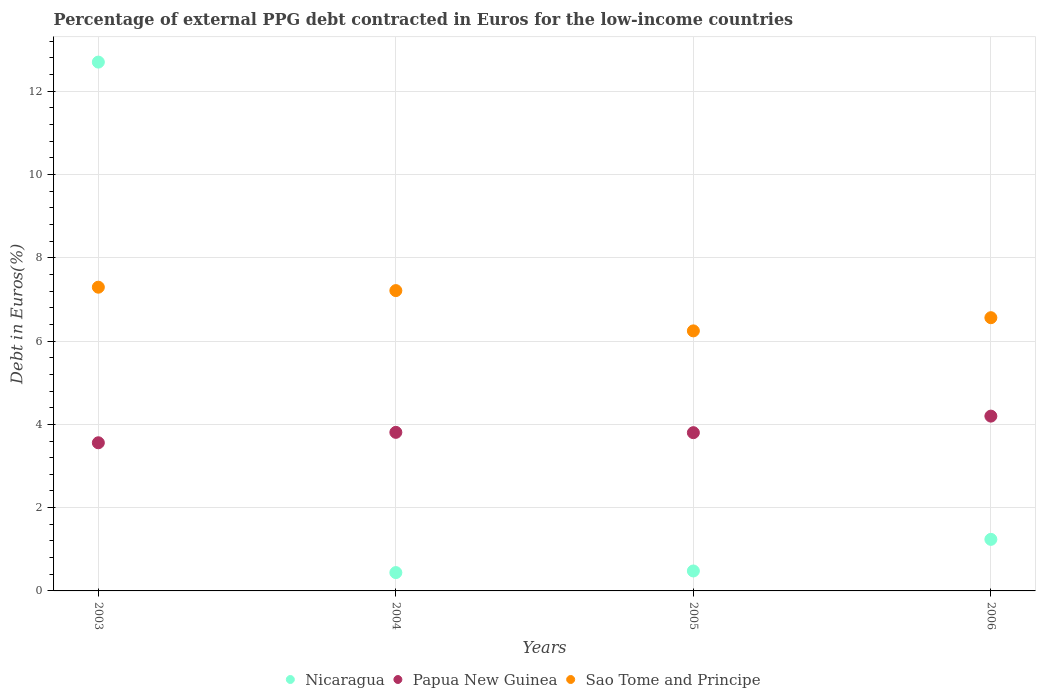What is the percentage of external PPG debt contracted in Euros in Nicaragua in 2006?
Give a very brief answer. 1.24. Across all years, what is the maximum percentage of external PPG debt contracted in Euros in Papua New Guinea?
Offer a terse response. 4.2. Across all years, what is the minimum percentage of external PPG debt contracted in Euros in Nicaragua?
Provide a short and direct response. 0.44. In which year was the percentage of external PPG debt contracted in Euros in Papua New Guinea maximum?
Provide a short and direct response. 2006. In which year was the percentage of external PPG debt contracted in Euros in Nicaragua minimum?
Keep it short and to the point. 2004. What is the total percentage of external PPG debt contracted in Euros in Nicaragua in the graph?
Provide a succinct answer. 14.86. What is the difference between the percentage of external PPG debt contracted in Euros in Sao Tome and Principe in 2003 and that in 2005?
Your answer should be very brief. 1.05. What is the difference between the percentage of external PPG debt contracted in Euros in Sao Tome and Principe in 2004 and the percentage of external PPG debt contracted in Euros in Nicaragua in 2005?
Make the answer very short. 6.73. What is the average percentage of external PPG debt contracted in Euros in Papua New Guinea per year?
Your answer should be very brief. 3.84. In the year 2006, what is the difference between the percentage of external PPG debt contracted in Euros in Papua New Guinea and percentage of external PPG debt contracted in Euros in Nicaragua?
Give a very brief answer. 2.96. What is the ratio of the percentage of external PPG debt contracted in Euros in Nicaragua in 2004 to that in 2006?
Provide a succinct answer. 0.36. Is the percentage of external PPG debt contracted in Euros in Papua New Guinea in 2003 less than that in 2005?
Your response must be concise. Yes. What is the difference between the highest and the second highest percentage of external PPG debt contracted in Euros in Nicaragua?
Offer a very short reply. 11.46. What is the difference between the highest and the lowest percentage of external PPG debt contracted in Euros in Sao Tome and Principe?
Your answer should be compact. 1.05. In how many years, is the percentage of external PPG debt contracted in Euros in Papua New Guinea greater than the average percentage of external PPG debt contracted in Euros in Papua New Guinea taken over all years?
Make the answer very short. 1. Is the sum of the percentage of external PPG debt contracted in Euros in Papua New Guinea in 2003 and 2004 greater than the maximum percentage of external PPG debt contracted in Euros in Sao Tome and Principe across all years?
Provide a short and direct response. Yes. Is it the case that in every year, the sum of the percentage of external PPG debt contracted in Euros in Sao Tome and Principe and percentage of external PPG debt contracted in Euros in Papua New Guinea  is greater than the percentage of external PPG debt contracted in Euros in Nicaragua?
Your answer should be very brief. No. Does the percentage of external PPG debt contracted in Euros in Sao Tome and Principe monotonically increase over the years?
Your answer should be very brief. No. Is the percentage of external PPG debt contracted in Euros in Nicaragua strictly greater than the percentage of external PPG debt contracted in Euros in Papua New Guinea over the years?
Offer a terse response. No. Is the percentage of external PPG debt contracted in Euros in Papua New Guinea strictly less than the percentage of external PPG debt contracted in Euros in Nicaragua over the years?
Your answer should be very brief. No. How many dotlines are there?
Keep it short and to the point. 3. How many years are there in the graph?
Make the answer very short. 4. Are the values on the major ticks of Y-axis written in scientific E-notation?
Keep it short and to the point. No. Does the graph contain any zero values?
Your response must be concise. No. Does the graph contain grids?
Your response must be concise. Yes. Where does the legend appear in the graph?
Give a very brief answer. Bottom center. How many legend labels are there?
Offer a very short reply. 3. How are the legend labels stacked?
Provide a short and direct response. Horizontal. What is the title of the graph?
Ensure brevity in your answer.  Percentage of external PPG debt contracted in Euros for the low-income countries. What is the label or title of the Y-axis?
Offer a very short reply. Debt in Euros(%). What is the Debt in Euros(%) in Nicaragua in 2003?
Provide a succinct answer. 12.7. What is the Debt in Euros(%) in Papua New Guinea in 2003?
Offer a very short reply. 3.56. What is the Debt in Euros(%) of Sao Tome and Principe in 2003?
Ensure brevity in your answer.  7.29. What is the Debt in Euros(%) in Nicaragua in 2004?
Provide a short and direct response. 0.44. What is the Debt in Euros(%) of Papua New Guinea in 2004?
Offer a terse response. 3.81. What is the Debt in Euros(%) of Sao Tome and Principe in 2004?
Ensure brevity in your answer.  7.21. What is the Debt in Euros(%) of Nicaragua in 2005?
Give a very brief answer. 0.48. What is the Debt in Euros(%) in Papua New Guinea in 2005?
Provide a short and direct response. 3.8. What is the Debt in Euros(%) of Sao Tome and Principe in 2005?
Provide a short and direct response. 6.24. What is the Debt in Euros(%) in Nicaragua in 2006?
Make the answer very short. 1.24. What is the Debt in Euros(%) of Papua New Guinea in 2006?
Keep it short and to the point. 4.2. What is the Debt in Euros(%) in Sao Tome and Principe in 2006?
Your answer should be very brief. 6.56. Across all years, what is the maximum Debt in Euros(%) of Nicaragua?
Your answer should be very brief. 12.7. Across all years, what is the maximum Debt in Euros(%) of Papua New Guinea?
Your answer should be compact. 4.2. Across all years, what is the maximum Debt in Euros(%) in Sao Tome and Principe?
Offer a terse response. 7.29. Across all years, what is the minimum Debt in Euros(%) in Nicaragua?
Your response must be concise. 0.44. Across all years, what is the minimum Debt in Euros(%) in Papua New Guinea?
Make the answer very short. 3.56. Across all years, what is the minimum Debt in Euros(%) in Sao Tome and Principe?
Your response must be concise. 6.24. What is the total Debt in Euros(%) in Nicaragua in the graph?
Make the answer very short. 14.86. What is the total Debt in Euros(%) in Papua New Guinea in the graph?
Keep it short and to the point. 15.36. What is the total Debt in Euros(%) in Sao Tome and Principe in the graph?
Make the answer very short. 27.31. What is the difference between the Debt in Euros(%) in Nicaragua in 2003 and that in 2004?
Give a very brief answer. 12.26. What is the difference between the Debt in Euros(%) of Papua New Guinea in 2003 and that in 2004?
Your answer should be very brief. -0.25. What is the difference between the Debt in Euros(%) of Sao Tome and Principe in 2003 and that in 2004?
Offer a terse response. 0.08. What is the difference between the Debt in Euros(%) in Nicaragua in 2003 and that in 2005?
Make the answer very short. 12.22. What is the difference between the Debt in Euros(%) of Papua New Guinea in 2003 and that in 2005?
Provide a succinct answer. -0.24. What is the difference between the Debt in Euros(%) in Sao Tome and Principe in 2003 and that in 2005?
Your response must be concise. 1.05. What is the difference between the Debt in Euros(%) of Nicaragua in 2003 and that in 2006?
Your answer should be compact. 11.46. What is the difference between the Debt in Euros(%) in Papua New Guinea in 2003 and that in 2006?
Offer a very short reply. -0.64. What is the difference between the Debt in Euros(%) of Sao Tome and Principe in 2003 and that in 2006?
Make the answer very short. 0.73. What is the difference between the Debt in Euros(%) of Nicaragua in 2004 and that in 2005?
Your response must be concise. -0.04. What is the difference between the Debt in Euros(%) in Papua New Guinea in 2004 and that in 2005?
Ensure brevity in your answer.  0.01. What is the difference between the Debt in Euros(%) in Sao Tome and Principe in 2004 and that in 2005?
Give a very brief answer. 0.97. What is the difference between the Debt in Euros(%) in Nicaragua in 2004 and that in 2006?
Your answer should be compact. -0.8. What is the difference between the Debt in Euros(%) in Papua New Guinea in 2004 and that in 2006?
Your answer should be very brief. -0.39. What is the difference between the Debt in Euros(%) in Sao Tome and Principe in 2004 and that in 2006?
Offer a terse response. 0.65. What is the difference between the Debt in Euros(%) of Nicaragua in 2005 and that in 2006?
Offer a very short reply. -0.76. What is the difference between the Debt in Euros(%) in Papua New Guinea in 2005 and that in 2006?
Your response must be concise. -0.4. What is the difference between the Debt in Euros(%) in Sao Tome and Principe in 2005 and that in 2006?
Offer a terse response. -0.32. What is the difference between the Debt in Euros(%) of Nicaragua in 2003 and the Debt in Euros(%) of Papua New Guinea in 2004?
Ensure brevity in your answer.  8.89. What is the difference between the Debt in Euros(%) of Nicaragua in 2003 and the Debt in Euros(%) of Sao Tome and Principe in 2004?
Make the answer very short. 5.49. What is the difference between the Debt in Euros(%) of Papua New Guinea in 2003 and the Debt in Euros(%) of Sao Tome and Principe in 2004?
Your response must be concise. -3.65. What is the difference between the Debt in Euros(%) of Nicaragua in 2003 and the Debt in Euros(%) of Papua New Guinea in 2005?
Give a very brief answer. 8.9. What is the difference between the Debt in Euros(%) in Nicaragua in 2003 and the Debt in Euros(%) in Sao Tome and Principe in 2005?
Give a very brief answer. 6.45. What is the difference between the Debt in Euros(%) of Papua New Guinea in 2003 and the Debt in Euros(%) of Sao Tome and Principe in 2005?
Ensure brevity in your answer.  -2.69. What is the difference between the Debt in Euros(%) of Nicaragua in 2003 and the Debt in Euros(%) of Papua New Guinea in 2006?
Offer a very short reply. 8.5. What is the difference between the Debt in Euros(%) of Nicaragua in 2003 and the Debt in Euros(%) of Sao Tome and Principe in 2006?
Provide a succinct answer. 6.14. What is the difference between the Debt in Euros(%) of Papua New Guinea in 2003 and the Debt in Euros(%) of Sao Tome and Principe in 2006?
Provide a succinct answer. -3. What is the difference between the Debt in Euros(%) in Nicaragua in 2004 and the Debt in Euros(%) in Papua New Guinea in 2005?
Keep it short and to the point. -3.36. What is the difference between the Debt in Euros(%) of Nicaragua in 2004 and the Debt in Euros(%) of Sao Tome and Principe in 2005?
Keep it short and to the point. -5.8. What is the difference between the Debt in Euros(%) of Papua New Guinea in 2004 and the Debt in Euros(%) of Sao Tome and Principe in 2005?
Offer a terse response. -2.44. What is the difference between the Debt in Euros(%) of Nicaragua in 2004 and the Debt in Euros(%) of Papua New Guinea in 2006?
Ensure brevity in your answer.  -3.76. What is the difference between the Debt in Euros(%) in Nicaragua in 2004 and the Debt in Euros(%) in Sao Tome and Principe in 2006?
Provide a short and direct response. -6.12. What is the difference between the Debt in Euros(%) in Papua New Guinea in 2004 and the Debt in Euros(%) in Sao Tome and Principe in 2006?
Offer a very short reply. -2.75. What is the difference between the Debt in Euros(%) of Nicaragua in 2005 and the Debt in Euros(%) of Papua New Guinea in 2006?
Ensure brevity in your answer.  -3.72. What is the difference between the Debt in Euros(%) of Nicaragua in 2005 and the Debt in Euros(%) of Sao Tome and Principe in 2006?
Offer a terse response. -6.08. What is the difference between the Debt in Euros(%) of Papua New Guinea in 2005 and the Debt in Euros(%) of Sao Tome and Principe in 2006?
Your answer should be very brief. -2.76. What is the average Debt in Euros(%) of Nicaragua per year?
Your answer should be compact. 3.71. What is the average Debt in Euros(%) in Papua New Guinea per year?
Your answer should be compact. 3.84. What is the average Debt in Euros(%) in Sao Tome and Principe per year?
Offer a terse response. 6.83. In the year 2003, what is the difference between the Debt in Euros(%) of Nicaragua and Debt in Euros(%) of Papua New Guinea?
Make the answer very short. 9.14. In the year 2003, what is the difference between the Debt in Euros(%) of Nicaragua and Debt in Euros(%) of Sao Tome and Principe?
Give a very brief answer. 5.41. In the year 2003, what is the difference between the Debt in Euros(%) of Papua New Guinea and Debt in Euros(%) of Sao Tome and Principe?
Your answer should be compact. -3.74. In the year 2004, what is the difference between the Debt in Euros(%) in Nicaragua and Debt in Euros(%) in Papua New Guinea?
Offer a very short reply. -3.37. In the year 2004, what is the difference between the Debt in Euros(%) in Nicaragua and Debt in Euros(%) in Sao Tome and Principe?
Keep it short and to the point. -6.77. In the year 2004, what is the difference between the Debt in Euros(%) in Papua New Guinea and Debt in Euros(%) in Sao Tome and Principe?
Ensure brevity in your answer.  -3.4. In the year 2005, what is the difference between the Debt in Euros(%) of Nicaragua and Debt in Euros(%) of Papua New Guinea?
Make the answer very short. -3.32. In the year 2005, what is the difference between the Debt in Euros(%) in Nicaragua and Debt in Euros(%) in Sao Tome and Principe?
Your answer should be compact. -5.77. In the year 2005, what is the difference between the Debt in Euros(%) of Papua New Guinea and Debt in Euros(%) of Sao Tome and Principe?
Keep it short and to the point. -2.44. In the year 2006, what is the difference between the Debt in Euros(%) in Nicaragua and Debt in Euros(%) in Papua New Guinea?
Give a very brief answer. -2.96. In the year 2006, what is the difference between the Debt in Euros(%) in Nicaragua and Debt in Euros(%) in Sao Tome and Principe?
Your answer should be compact. -5.32. In the year 2006, what is the difference between the Debt in Euros(%) in Papua New Guinea and Debt in Euros(%) in Sao Tome and Principe?
Make the answer very short. -2.36. What is the ratio of the Debt in Euros(%) of Nicaragua in 2003 to that in 2004?
Offer a terse response. 28.85. What is the ratio of the Debt in Euros(%) in Papua New Guinea in 2003 to that in 2004?
Provide a short and direct response. 0.93. What is the ratio of the Debt in Euros(%) of Sao Tome and Principe in 2003 to that in 2004?
Your answer should be very brief. 1.01. What is the ratio of the Debt in Euros(%) of Nicaragua in 2003 to that in 2005?
Give a very brief answer. 26.51. What is the ratio of the Debt in Euros(%) of Papua New Guinea in 2003 to that in 2005?
Your response must be concise. 0.94. What is the ratio of the Debt in Euros(%) of Sao Tome and Principe in 2003 to that in 2005?
Your answer should be very brief. 1.17. What is the ratio of the Debt in Euros(%) in Nicaragua in 2003 to that in 2006?
Keep it short and to the point. 10.26. What is the ratio of the Debt in Euros(%) in Papua New Guinea in 2003 to that in 2006?
Give a very brief answer. 0.85. What is the ratio of the Debt in Euros(%) in Sao Tome and Principe in 2003 to that in 2006?
Your response must be concise. 1.11. What is the ratio of the Debt in Euros(%) in Nicaragua in 2004 to that in 2005?
Your answer should be compact. 0.92. What is the ratio of the Debt in Euros(%) in Papua New Guinea in 2004 to that in 2005?
Offer a very short reply. 1. What is the ratio of the Debt in Euros(%) in Sao Tome and Principe in 2004 to that in 2005?
Give a very brief answer. 1.15. What is the ratio of the Debt in Euros(%) of Nicaragua in 2004 to that in 2006?
Offer a terse response. 0.36. What is the ratio of the Debt in Euros(%) of Papua New Guinea in 2004 to that in 2006?
Make the answer very short. 0.91. What is the ratio of the Debt in Euros(%) in Sao Tome and Principe in 2004 to that in 2006?
Offer a terse response. 1.1. What is the ratio of the Debt in Euros(%) of Nicaragua in 2005 to that in 2006?
Your answer should be compact. 0.39. What is the ratio of the Debt in Euros(%) of Papua New Guinea in 2005 to that in 2006?
Offer a very short reply. 0.91. What is the ratio of the Debt in Euros(%) in Sao Tome and Principe in 2005 to that in 2006?
Your response must be concise. 0.95. What is the difference between the highest and the second highest Debt in Euros(%) in Nicaragua?
Provide a short and direct response. 11.46. What is the difference between the highest and the second highest Debt in Euros(%) in Papua New Guinea?
Ensure brevity in your answer.  0.39. What is the difference between the highest and the second highest Debt in Euros(%) in Sao Tome and Principe?
Your response must be concise. 0.08. What is the difference between the highest and the lowest Debt in Euros(%) of Nicaragua?
Your response must be concise. 12.26. What is the difference between the highest and the lowest Debt in Euros(%) in Papua New Guinea?
Your response must be concise. 0.64. What is the difference between the highest and the lowest Debt in Euros(%) of Sao Tome and Principe?
Offer a terse response. 1.05. 